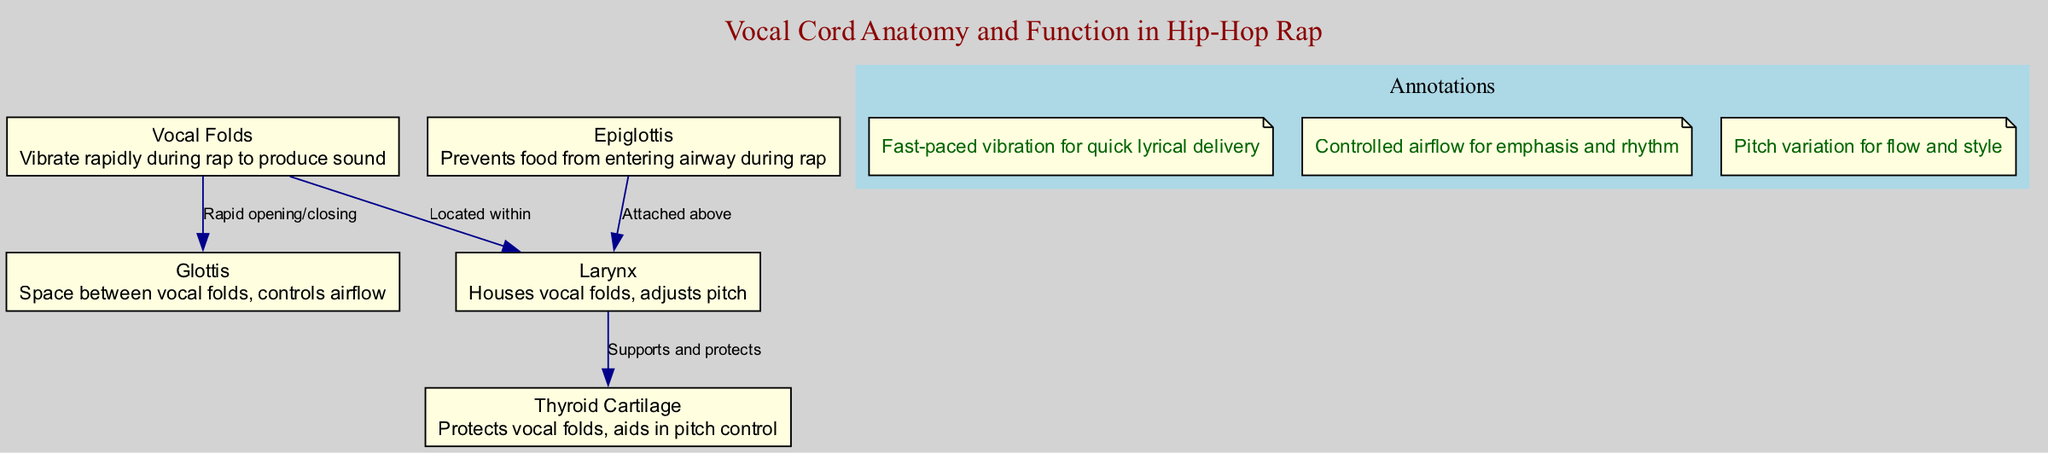What are the vocal folds responsible for during rap? The vocal folds vibrate rapidly to produce sound, which is essential for delivering lyrics quickly in rap vocals.
Answer: Vibrate rapidly How many nodes are in the diagram? There are five nodes in the diagram, each representing a different part of vocal cord anatomy.
Answer: Five Which structure prevents food from entering the airway during rap? The epiglottis is responsible for preventing food from entering the airway while rapping, ensuring that airflow remains unobstructed.
Answer: Epiglottis What controls the airflow between the vocal folds? The glottis controls the airflow between the vocal folds, allowing for variations in delivery and rhythm during performance.
Answer: Glottis What function does the thyroid cartilage serve? The thyroid cartilage protects the vocal folds and aids in pitch control, which is crucial for adjusting flow and style in rap music.
Answer: Protects vocal folds How are the vocal folds connected to the larynx? The vocal folds are located within the larynx, which houses them and allows for adjustments in pitch during vocal performance.
Answer: Located within What does rapid opening and closing of the vocal folds achieve? The rapid opening and closing of the vocal folds creates fast-paced vibration, necessary for quick lyrical delivery in rap.
Answer: Quick lyrical delivery Which anatomical part supports and protects the larynx? The thyroid cartilage supports and protects the larynx, contributing to the overall functionality and sound production during rap.
Answer: Thyroid cartilage What is a key aspect of pitch variation in rap? Adjustments in pitch, facilitated by the larynx, enable variations in flow and style, adding uniqueness to rap vocals.
Answer: Pitch variation 